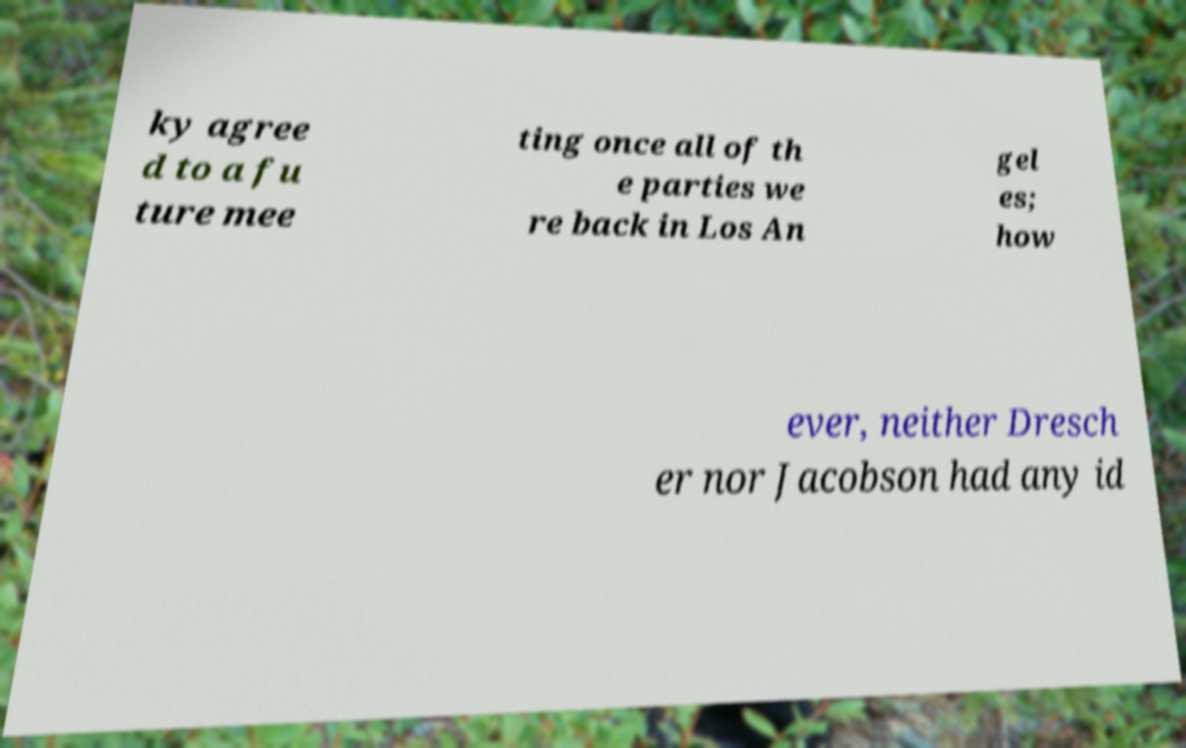Can you read and provide the text displayed in the image?This photo seems to have some interesting text. Can you extract and type it out for me? ky agree d to a fu ture mee ting once all of th e parties we re back in Los An gel es; how ever, neither Dresch er nor Jacobson had any id 